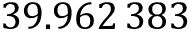Convert formula to latex. <formula><loc_0><loc_0><loc_500><loc_500>3 9 . 9 6 2 \, 3 8 3</formula> 